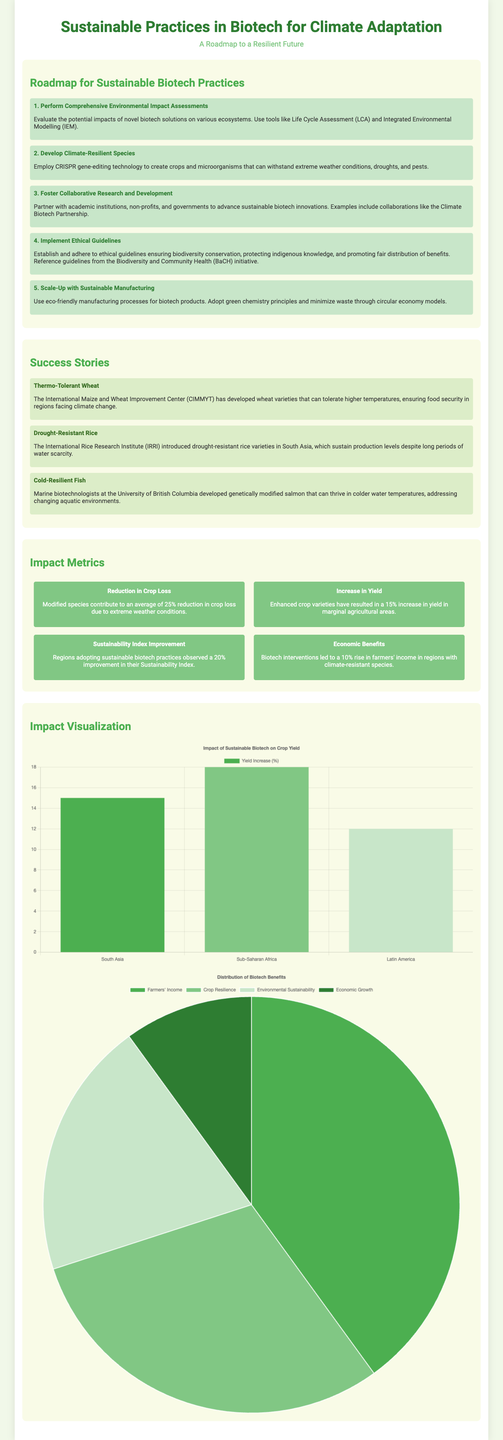what is the title of the poster? The title of the poster is prominently displayed at the top, summarizing its main theme.
Answer: Sustainable Practices in Biotech for Climate Adaptation what step involves developing climate-resilient species? This step is part of the roadmap focusing on creating varieties that can withstand challenging environmental conditions.
Answer: Develop Climate-Resilient Species which institute developed thermo-tolerant wheat? This information is provided in the success stories section, identifying the organization behind this innovation.
Answer: CIMMYT what is the average reduction in crop loss due to modified species? The document presents impact metrics that quantify the effectiveness of biotech interventions on crop loss.
Answer: 25% how many steps are in the roadmap for sustainable biotech practices? The roadmap section outlines specific actions, allowing us to count the listed items.
Answer: 5 what is the name of the initiative that promotes ethical guidelines in biotech? This name reveals efforts toward responsible biotechnological development mentioned in the roadmap.
Answer: BaCH what percentage increase in yield is reported for enhanced crop varieties? The question seeks specific metrics regarding yield improvements as highlighted in the impact metrics.
Answer: 15% which crop variety was introduced by the International Rice Research Institute? This question focuses on a specific success story, identifying the crop developed for climate resilience.
Answer: Drought-Resistant Rice 